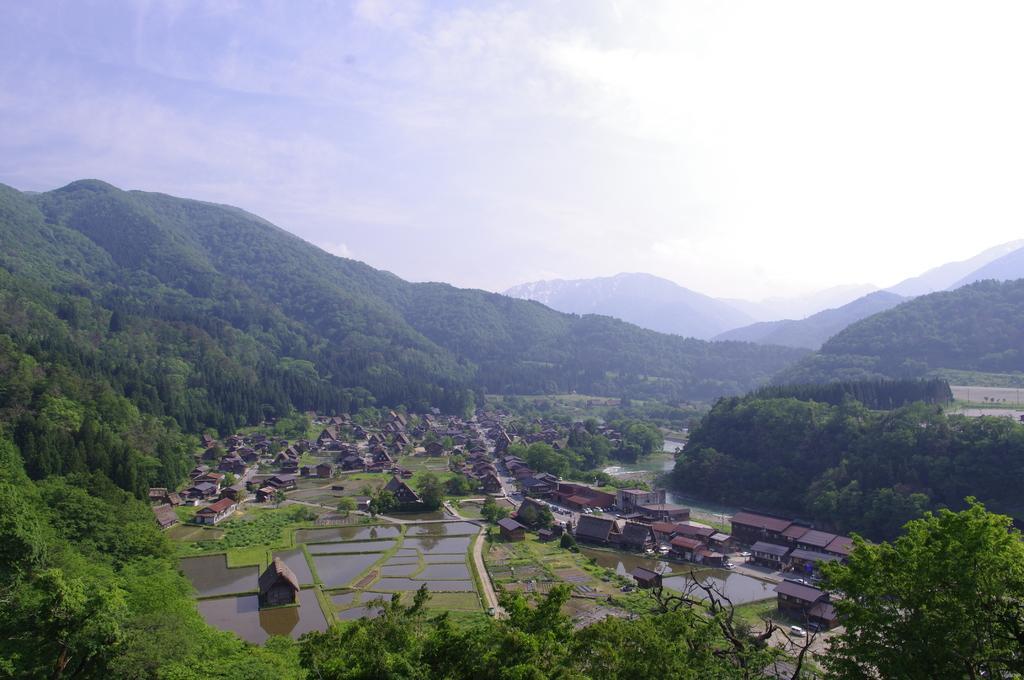How would you summarize this image in a sentence or two? In the middle of image on the ground there are many houses with roofs, fields filled with water and also there are few trees. To the bottom corner of the image there are trees. And in the background there are many hills with the trees. To the top of the image there is a sky. 